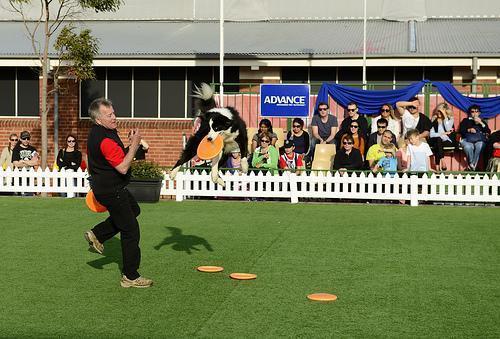How many frisbees are on the ground?
Give a very brief answer. 3. How many frisbees does the dog have?
Give a very brief answer. 1. How many trees are there?
Give a very brief answer. 1. How many dogs are catching a frisbee?
Give a very brief answer. 1. 